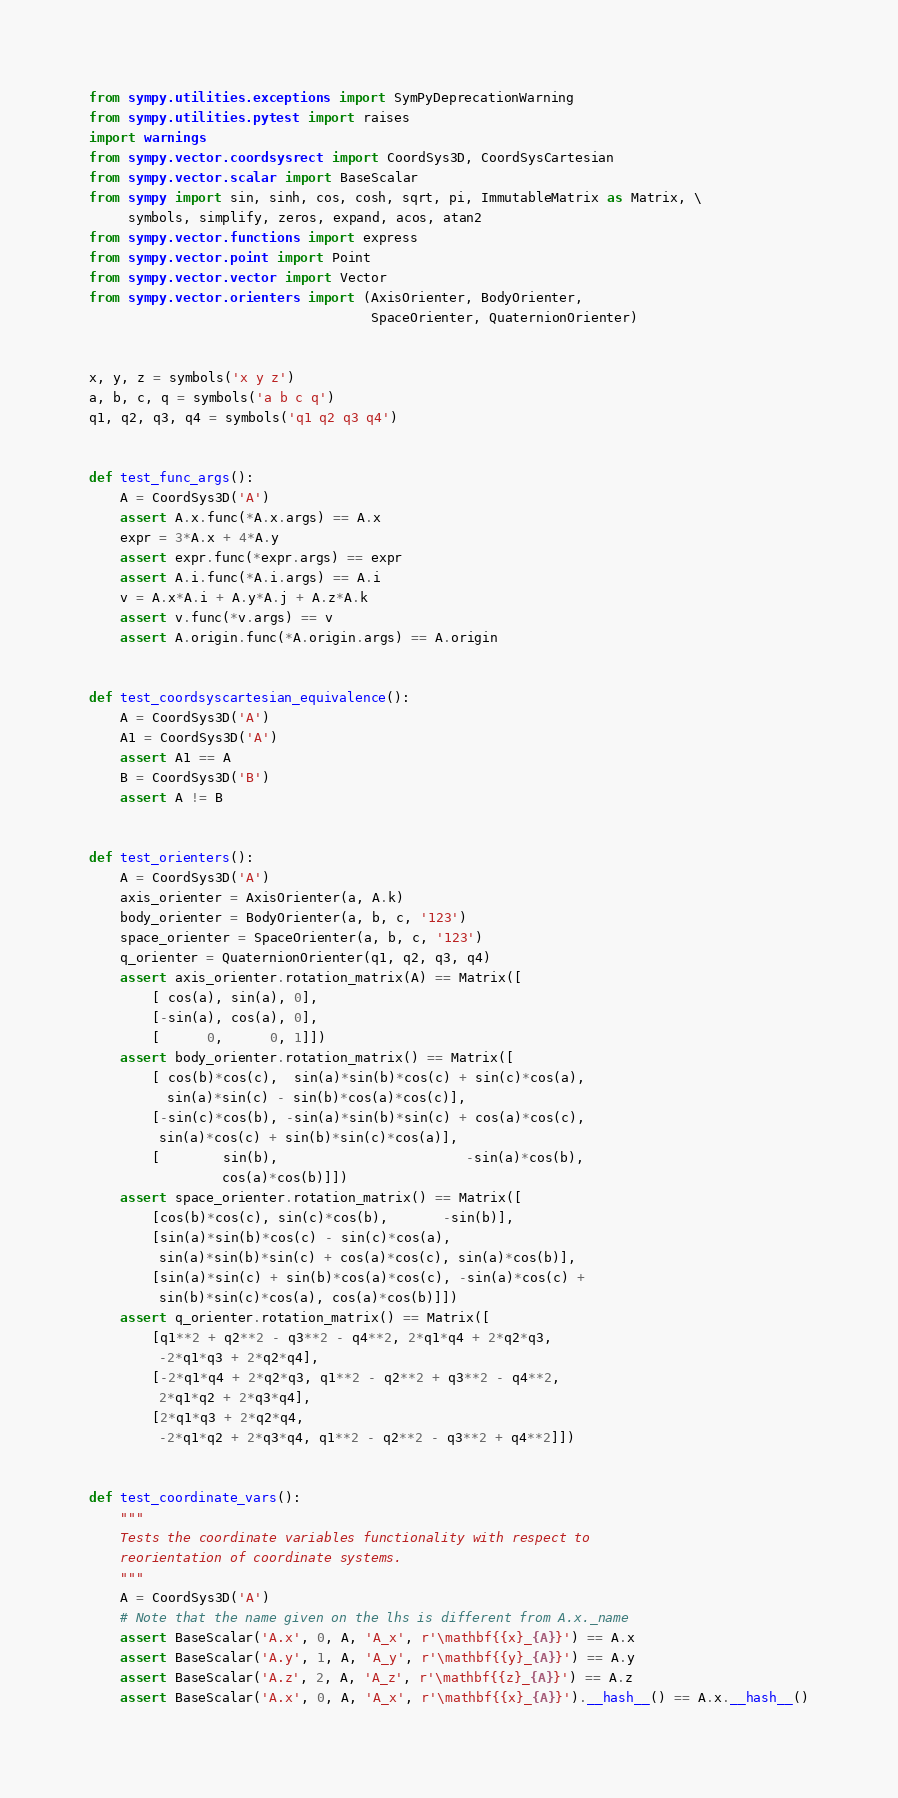<code> <loc_0><loc_0><loc_500><loc_500><_Python_>from sympy.utilities.exceptions import SymPyDeprecationWarning
from sympy.utilities.pytest import raises
import warnings
from sympy.vector.coordsysrect import CoordSys3D, CoordSysCartesian
from sympy.vector.scalar import BaseScalar
from sympy import sin, sinh, cos, cosh, sqrt, pi, ImmutableMatrix as Matrix, \
     symbols, simplify, zeros, expand, acos, atan2
from sympy.vector.functions import express
from sympy.vector.point import Point
from sympy.vector.vector import Vector
from sympy.vector.orienters import (AxisOrienter, BodyOrienter,
                                    SpaceOrienter, QuaternionOrienter)


x, y, z = symbols('x y z')
a, b, c, q = symbols('a b c q')
q1, q2, q3, q4 = symbols('q1 q2 q3 q4')


def test_func_args():
    A = CoordSys3D('A')
    assert A.x.func(*A.x.args) == A.x
    expr = 3*A.x + 4*A.y
    assert expr.func(*expr.args) == expr
    assert A.i.func(*A.i.args) == A.i
    v = A.x*A.i + A.y*A.j + A.z*A.k
    assert v.func(*v.args) == v
    assert A.origin.func(*A.origin.args) == A.origin


def test_coordsyscartesian_equivalence():
    A = CoordSys3D('A')
    A1 = CoordSys3D('A')
    assert A1 == A
    B = CoordSys3D('B')
    assert A != B


def test_orienters():
    A = CoordSys3D('A')
    axis_orienter = AxisOrienter(a, A.k)
    body_orienter = BodyOrienter(a, b, c, '123')
    space_orienter = SpaceOrienter(a, b, c, '123')
    q_orienter = QuaternionOrienter(q1, q2, q3, q4)
    assert axis_orienter.rotation_matrix(A) == Matrix([
        [ cos(a), sin(a), 0],
        [-sin(a), cos(a), 0],
        [      0,      0, 1]])
    assert body_orienter.rotation_matrix() == Matrix([
        [ cos(b)*cos(c),  sin(a)*sin(b)*cos(c) + sin(c)*cos(a),
          sin(a)*sin(c) - sin(b)*cos(a)*cos(c)],
        [-sin(c)*cos(b), -sin(a)*sin(b)*sin(c) + cos(a)*cos(c),
         sin(a)*cos(c) + sin(b)*sin(c)*cos(a)],
        [        sin(b),                        -sin(a)*cos(b),
                 cos(a)*cos(b)]])
    assert space_orienter.rotation_matrix() == Matrix([
        [cos(b)*cos(c), sin(c)*cos(b),       -sin(b)],
        [sin(a)*sin(b)*cos(c) - sin(c)*cos(a),
         sin(a)*sin(b)*sin(c) + cos(a)*cos(c), sin(a)*cos(b)],
        [sin(a)*sin(c) + sin(b)*cos(a)*cos(c), -sin(a)*cos(c) +
         sin(b)*sin(c)*cos(a), cos(a)*cos(b)]])
    assert q_orienter.rotation_matrix() == Matrix([
        [q1**2 + q2**2 - q3**2 - q4**2, 2*q1*q4 + 2*q2*q3,
         -2*q1*q3 + 2*q2*q4],
        [-2*q1*q4 + 2*q2*q3, q1**2 - q2**2 + q3**2 - q4**2,
         2*q1*q2 + 2*q3*q4],
        [2*q1*q3 + 2*q2*q4,
         -2*q1*q2 + 2*q3*q4, q1**2 - q2**2 - q3**2 + q4**2]])


def test_coordinate_vars():
    """
    Tests the coordinate variables functionality with respect to
    reorientation of coordinate systems.
    """
    A = CoordSys3D('A')
    # Note that the name given on the lhs is different from A.x._name
    assert BaseScalar('A.x', 0, A, 'A_x', r'\mathbf{{x}_{A}}') == A.x
    assert BaseScalar('A.y', 1, A, 'A_y', r'\mathbf{{y}_{A}}') == A.y
    assert BaseScalar('A.z', 2, A, 'A_z', r'\mathbf{{z}_{A}}') == A.z
    assert BaseScalar('A.x', 0, A, 'A_x', r'\mathbf{{x}_{A}}').__hash__() == A.x.__hash__()</code> 